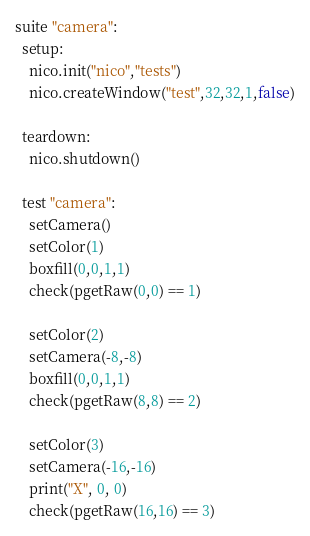<code> <loc_0><loc_0><loc_500><loc_500><_Nim_>suite "camera":
  setup:
    nico.init("nico","tests")
    nico.createWindow("test",32,32,1,false)

  teardown:
    nico.shutdown()

  test "camera":
    setCamera()
    setColor(1)
    boxfill(0,0,1,1)
    check(pgetRaw(0,0) == 1)

    setColor(2)
    setCamera(-8,-8)
    boxfill(0,0,1,1)
    check(pgetRaw(8,8) == 2)

    setColor(3)
    setCamera(-16,-16)
    print("X", 0, 0)
    check(pgetRaw(16,16) == 3)
</code> 